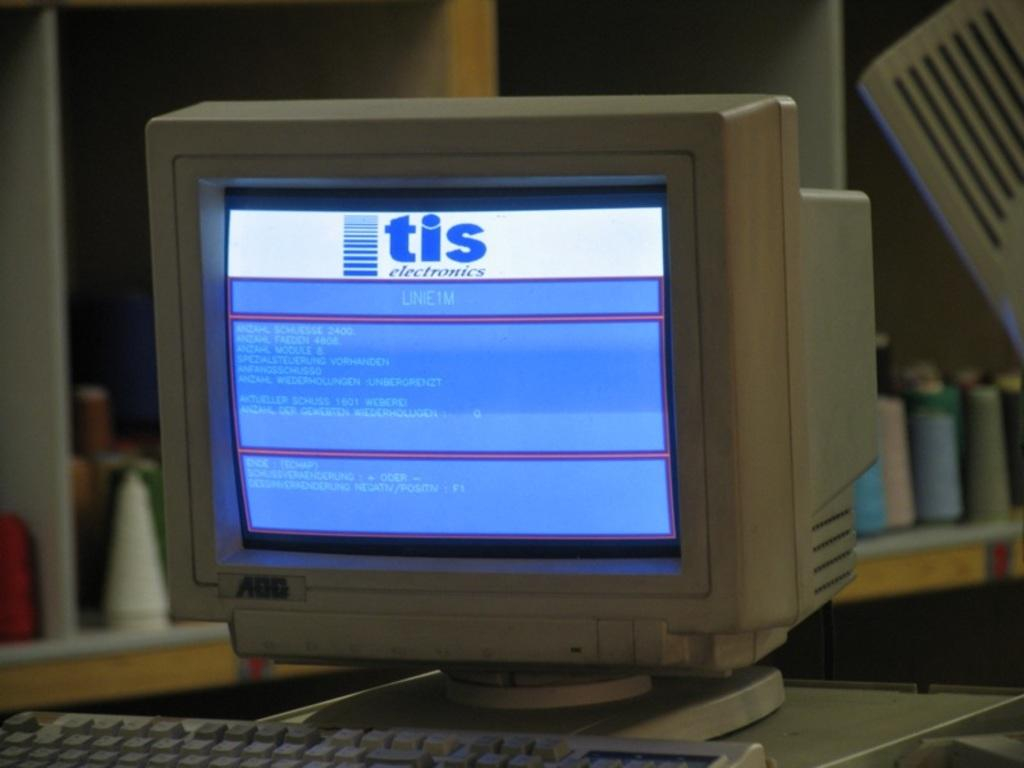<image>
Offer a succinct explanation of the picture presented. an old computer monitor with a page titled 'tis electronics' 